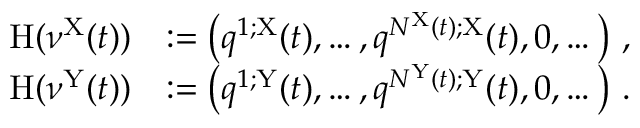<formula> <loc_0><loc_0><loc_500><loc_500>\begin{array} { r l } { H ( \nu ^ { X } ( t ) ) } & { \colon = \left ( q ^ { 1 ; X } ( t ) , \dots , q ^ { N ^ { X } ( t ) ; X } ( t ) , 0 , \dots \right ) \, , } \\ { H ( \nu ^ { Y } ( t ) ) } & { \colon = \left ( q ^ { 1 ; Y } ( t ) , \dots , q ^ { N ^ { Y } ( t ) ; Y } ( t ) , 0 , \dots \right ) \, . } \end{array}</formula> 